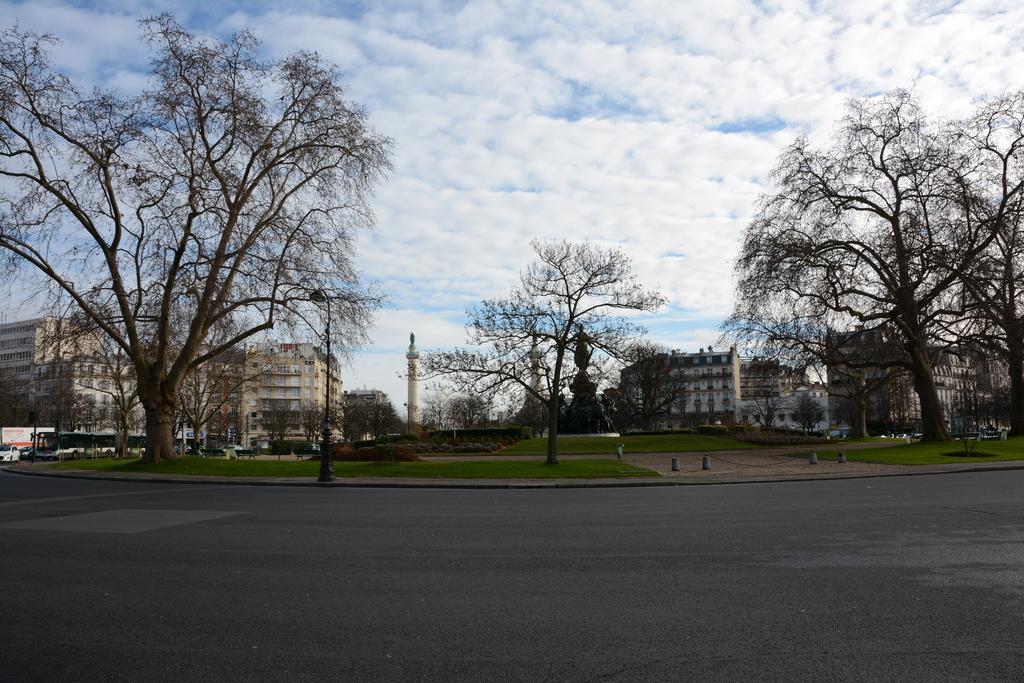How would you summarize this image in a sentence or two? This image is clicked outside. There are trees in the middle. There are buildings in the middle. There are statues in the middle. There are vehicles on the left side. There is sky at the top. 